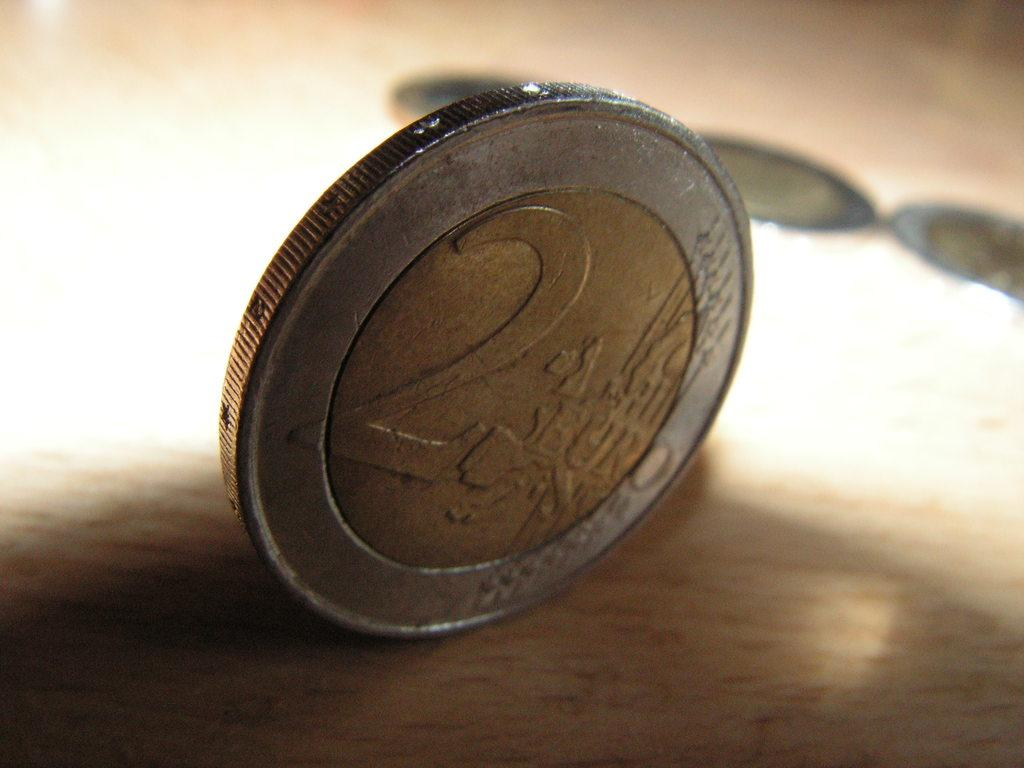<image>
Describe the image concisely. A 2 Euro coin sits on its edge on a wooden table. 